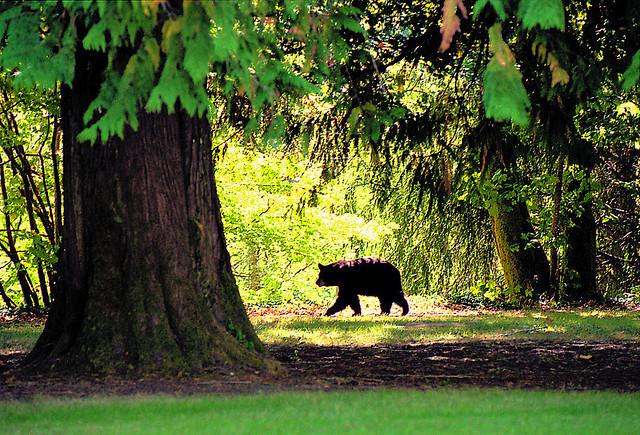Is the bear in an enclosure?
Short answer required. No. Is that animal a mammal?
Quick response, please. Yes. What type of animal is it?
Be succinct. Bear. What time of day is it?
Keep it brief. Afternoon. 